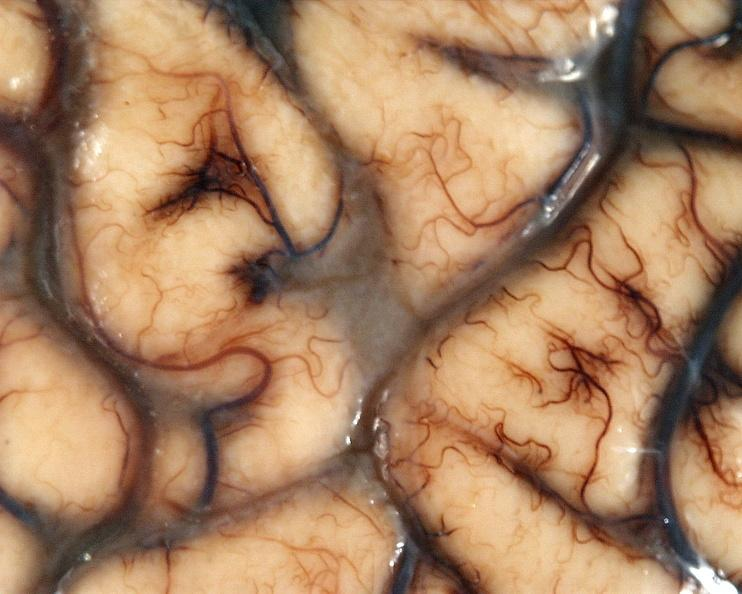what does this image show?
Answer the question using a single word or phrase. Brain 